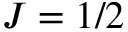Convert formula to latex. <formula><loc_0><loc_0><loc_500><loc_500>J = 1 / 2</formula> 